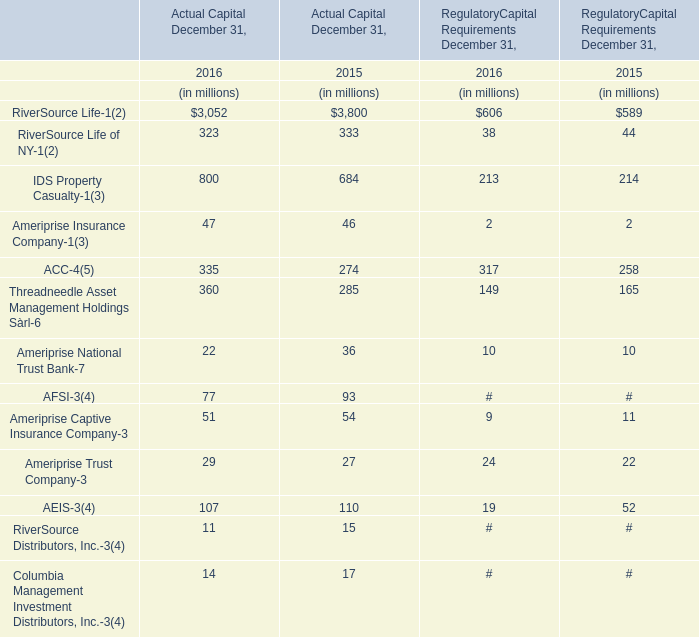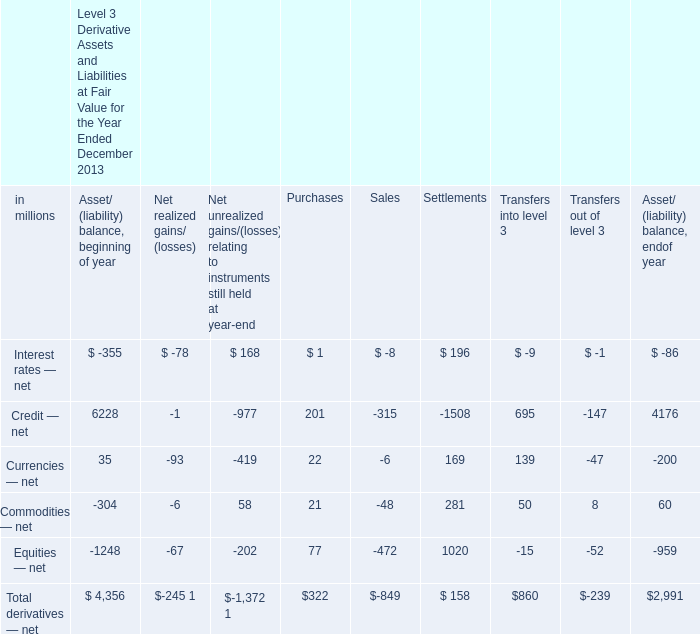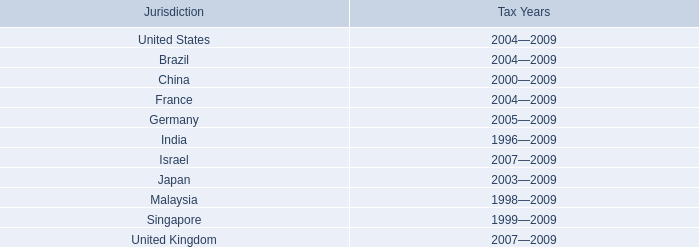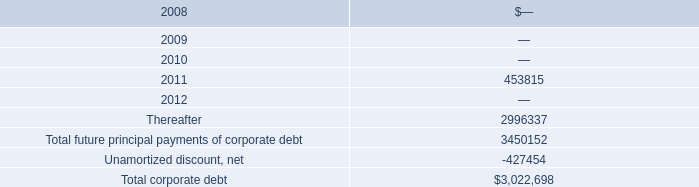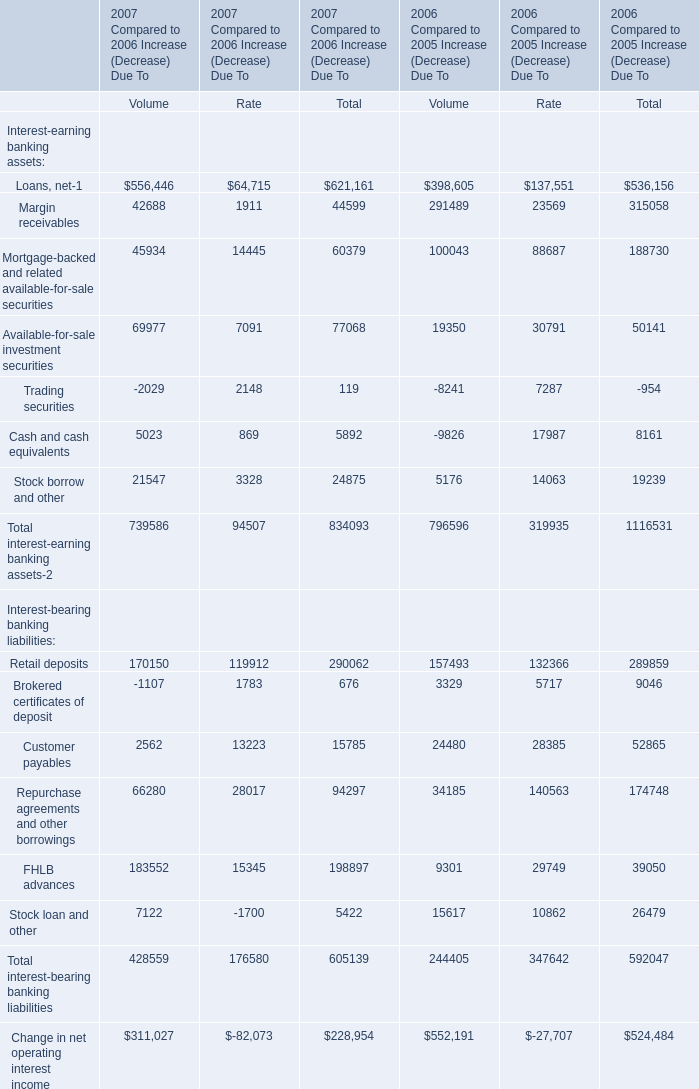what is the highest total amount of Mortgage-backed and related available-for-sale securities? 
Computations: (60379 + 188730)
Answer: 249109.0. 